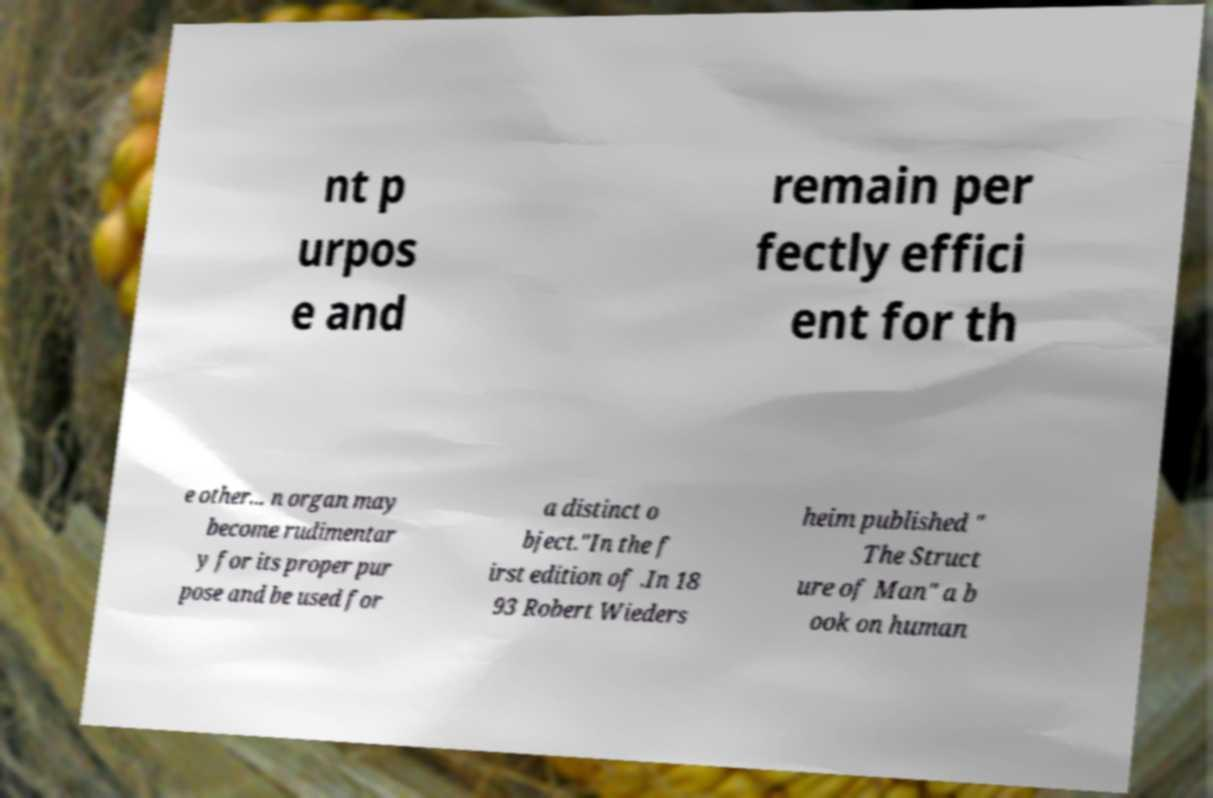There's text embedded in this image that I need extracted. Can you transcribe it verbatim? nt p urpos e and remain per fectly effici ent for th e other... n organ may become rudimentar y for its proper pur pose and be used for a distinct o bject."In the f irst edition of .In 18 93 Robert Wieders heim published " The Struct ure of Man" a b ook on human 